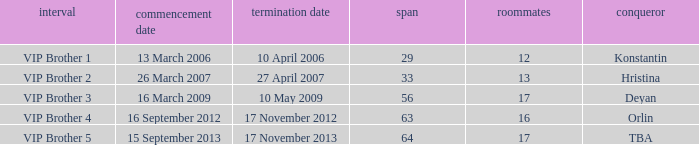What final date had 16 housemates? 17 November 2012. 